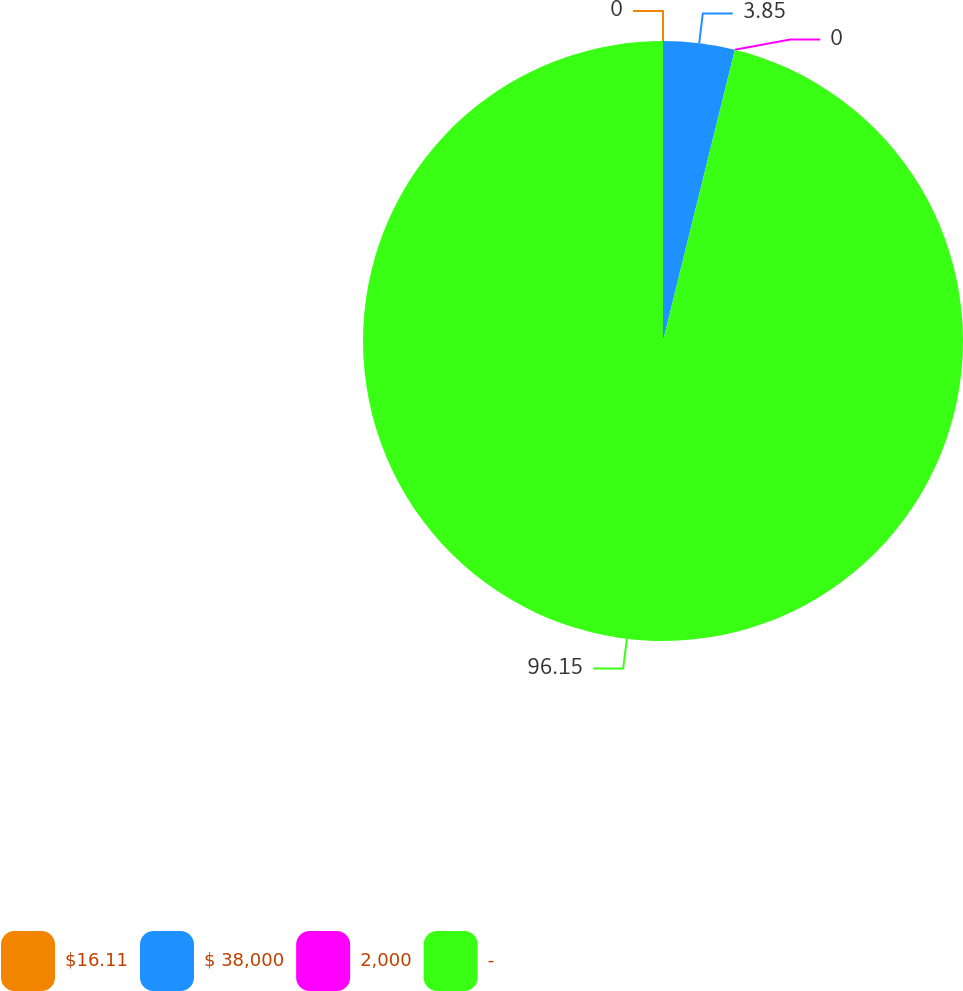Convert chart to OTSL. <chart><loc_0><loc_0><loc_500><loc_500><pie_chart><fcel>$16.11<fcel>$ 38,000<fcel>2,000<fcel>-<nl><fcel>0.0%<fcel>3.85%<fcel>0.0%<fcel>96.15%<nl></chart> 